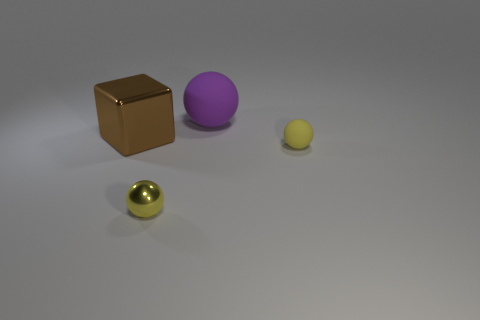Can you describe the composition of the scene? The image shows a simple composition with four objects placed on a flat surface. From left to right, there's a shiny golden sphere, a brown cube, a large purple sphere, and a smaller yellowish sphere. The lighting suggests an indoor setting with a soft shadow cast by each object. 